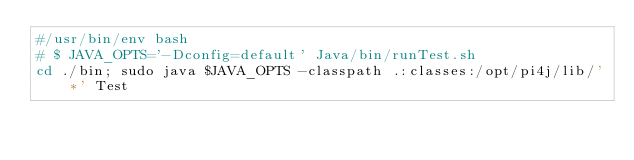<code> <loc_0><loc_0><loc_500><loc_500><_Bash_>#/usr/bin/env bash
# $ JAVA_OPTS='-Dconfig=default' Java/bin/runTest.sh
cd ./bin; sudo java $JAVA_OPTS -classpath .:classes:/opt/pi4j/lib/'*' Test</code> 